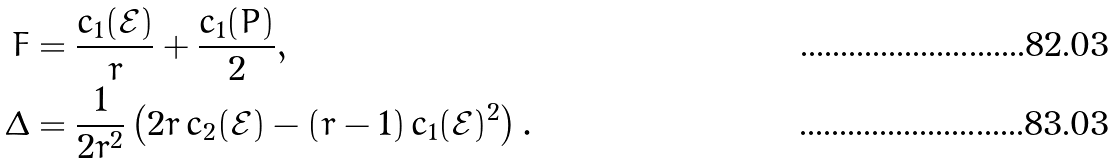<formula> <loc_0><loc_0><loc_500><loc_500>F & = \frac { c _ { 1 } ( \mathcal { E } ) } { r } + \frac { c _ { 1 } ( P ) } { 2 } , \\ \Delta & = \frac { 1 } { 2 r ^ { 2 } } \left ( 2 r \, c _ { 2 } ( \mathcal { E } ) - ( r - 1 ) \, c _ { 1 } ( \mathcal { E } ) ^ { 2 } \right ) .</formula> 